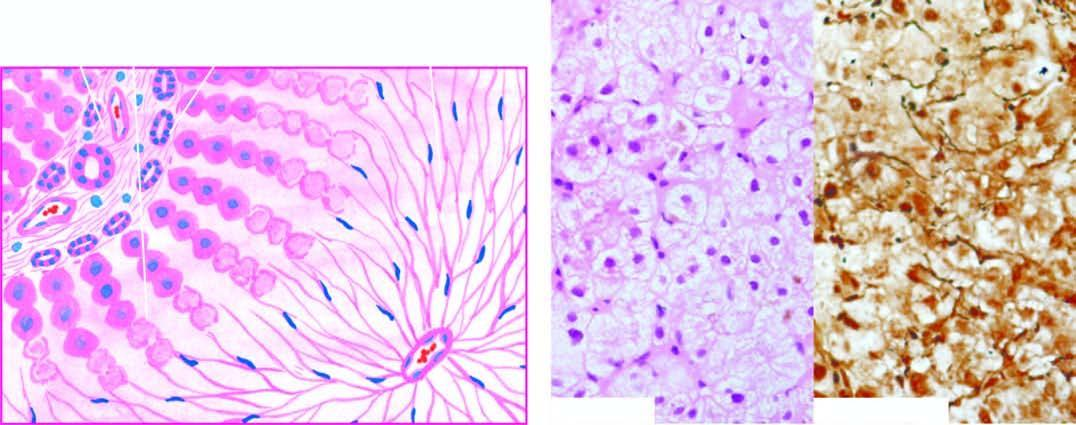s the cut surface no significant inflammation or fibrosis?
Answer the question using a single word or phrase. No 